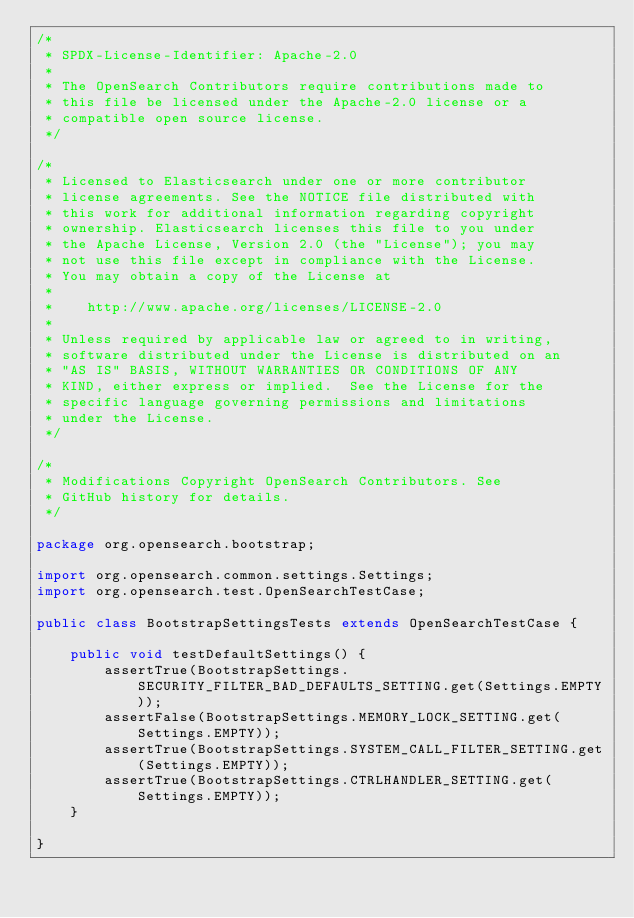Convert code to text. <code><loc_0><loc_0><loc_500><loc_500><_Java_>/*
 * SPDX-License-Identifier: Apache-2.0
 *
 * The OpenSearch Contributors require contributions made to
 * this file be licensed under the Apache-2.0 license or a
 * compatible open source license.
 */

/*
 * Licensed to Elasticsearch under one or more contributor
 * license agreements. See the NOTICE file distributed with
 * this work for additional information regarding copyright
 * ownership. Elasticsearch licenses this file to you under
 * the Apache License, Version 2.0 (the "License"); you may
 * not use this file except in compliance with the License.
 * You may obtain a copy of the License at
 *
 *    http://www.apache.org/licenses/LICENSE-2.0
 *
 * Unless required by applicable law or agreed to in writing,
 * software distributed under the License is distributed on an
 * "AS IS" BASIS, WITHOUT WARRANTIES OR CONDITIONS OF ANY
 * KIND, either express or implied.  See the License for the
 * specific language governing permissions and limitations
 * under the License.
 */

/*
 * Modifications Copyright OpenSearch Contributors. See
 * GitHub history for details.
 */

package org.opensearch.bootstrap;

import org.opensearch.common.settings.Settings;
import org.opensearch.test.OpenSearchTestCase;

public class BootstrapSettingsTests extends OpenSearchTestCase {

    public void testDefaultSettings() {
        assertTrue(BootstrapSettings.SECURITY_FILTER_BAD_DEFAULTS_SETTING.get(Settings.EMPTY));
        assertFalse(BootstrapSettings.MEMORY_LOCK_SETTING.get(Settings.EMPTY));
        assertTrue(BootstrapSettings.SYSTEM_CALL_FILTER_SETTING.get(Settings.EMPTY));
        assertTrue(BootstrapSettings.CTRLHANDLER_SETTING.get(Settings.EMPTY));
    }

}
</code> 